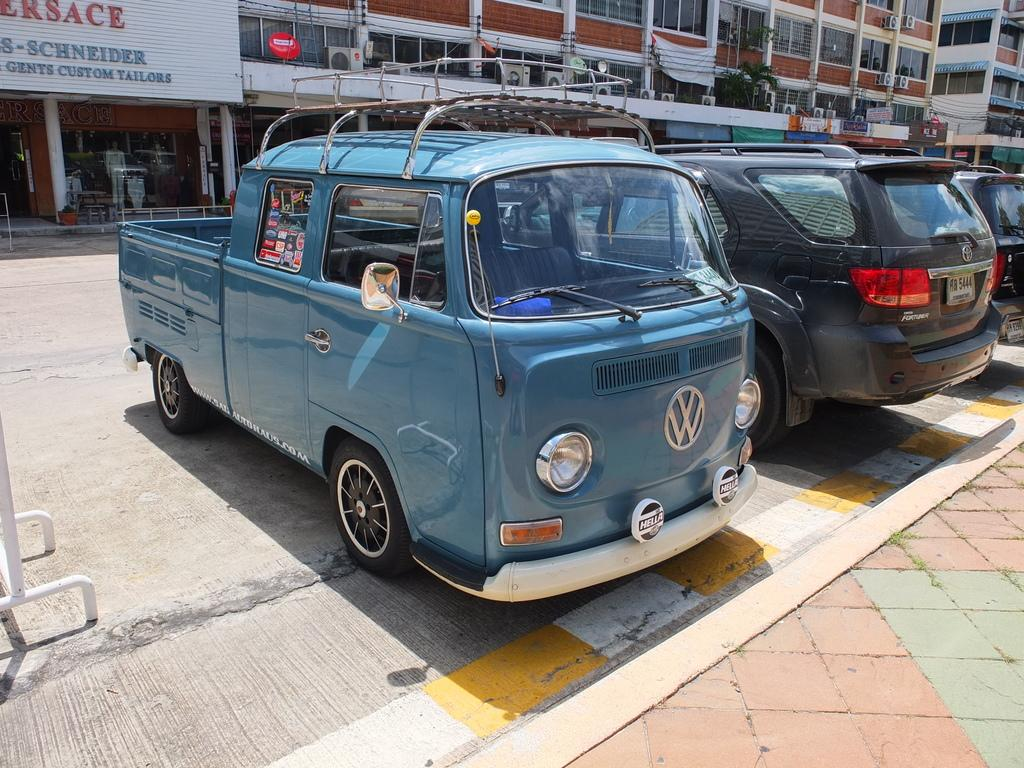What can be seen in the image that is used for transportation? There are cars parked in the image. What type of structures are visible in the image? There are buildings with windows in the image. Can you describe any signage or labels in the image? There is a name board attached to a building wall in the image. What type of rose can be seen growing near the cars in the image? There is no rose present in the image; it features cars parked near buildings. 